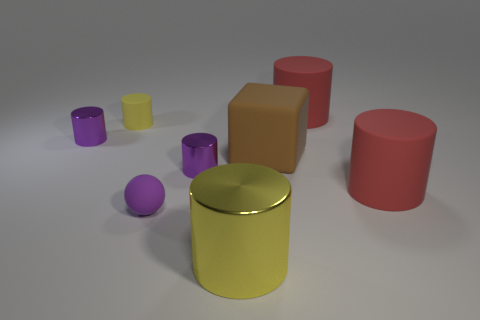How many objects are there, and can you categorize them? There are a total of seven objects in the image, which can be categorized into spheres, cylinders, and cubes based on their shapes. Which shape has the most objects? The cylindrical shape is the most common, with three objects in that form. 